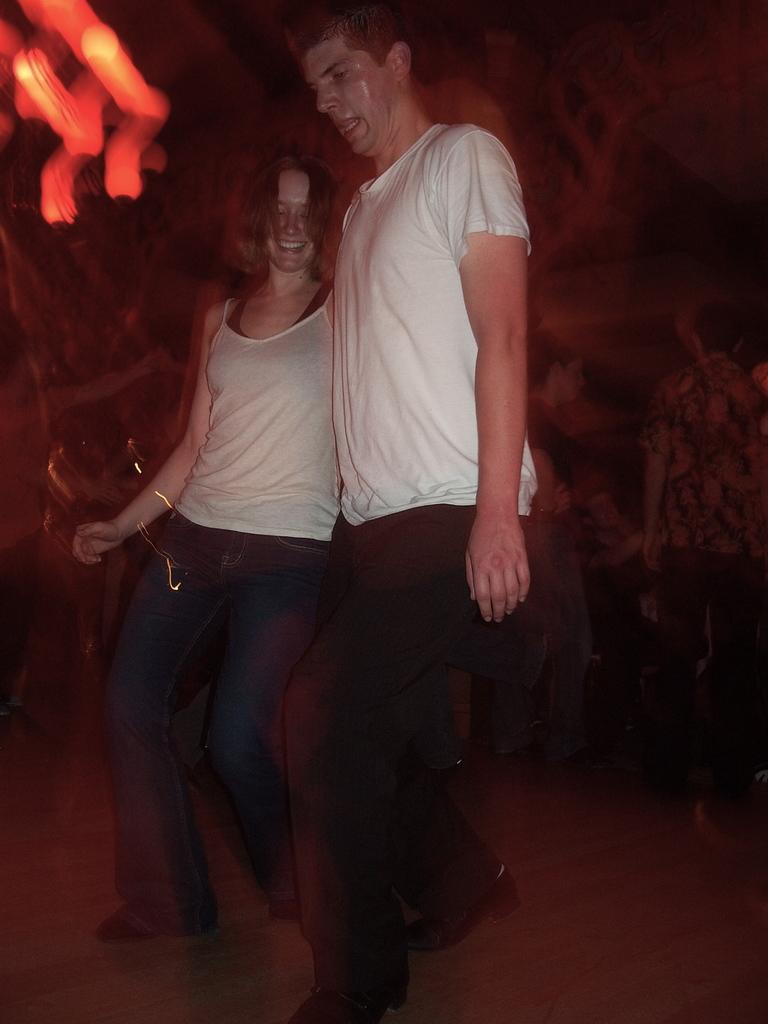How many people are in the image? There are two people in the image, a man and a woman. What are the man and woman doing in the image? The man and woman are standing. Can you describe the positions of the man and woman in the image? Unfortunately, the provided facts do not give enough information to describe their positions. What color is the robin perched on the woman's thumb in the image? There is no robin or thumb present in the image; it only features a man and a woman standing. 